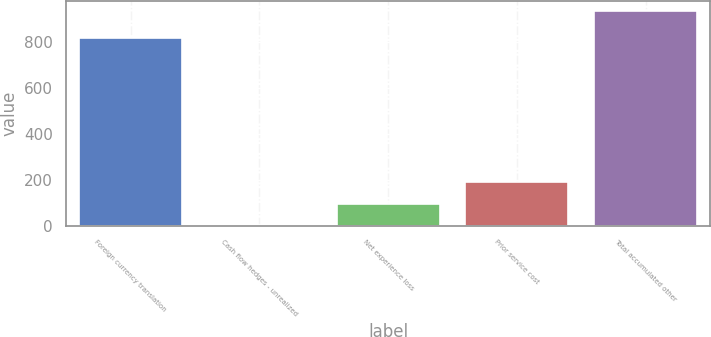Convert chart. <chart><loc_0><loc_0><loc_500><loc_500><bar_chart><fcel>Foreign currency translation<fcel>Cash flow hedges - unrealized<fcel>Net experience loss<fcel>Prior service cost<fcel>Total accumulated other<nl><fcel>817<fcel>3<fcel>95.8<fcel>188.6<fcel>931<nl></chart> 